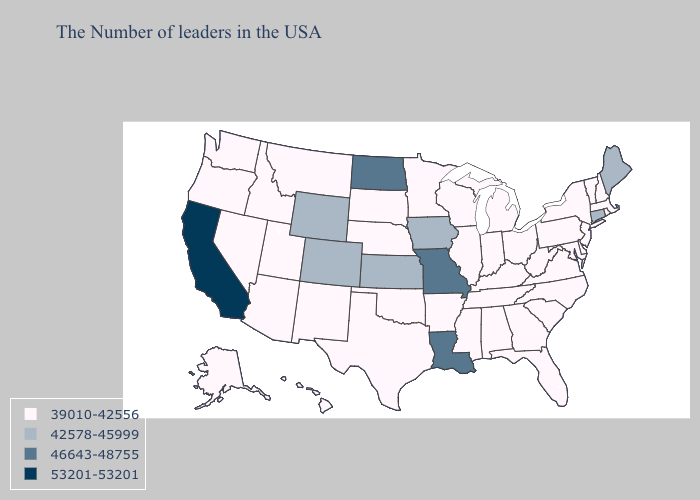Does the first symbol in the legend represent the smallest category?
Quick response, please. Yes. Among the states that border Rhode Island , does Connecticut have the lowest value?
Give a very brief answer. No. Name the states that have a value in the range 53201-53201?
Write a very short answer. California. Which states hav the highest value in the MidWest?
Short answer required. Missouri, North Dakota. Name the states that have a value in the range 53201-53201?
Keep it brief. California. Does the first symbol in the legend represent the smallest category?
Answer briefly. Yes. Which states have the lowest value in the USA?
Quick response, please. Massachusetts, Rhode Island, New Hampshire, Vermont, New York, New Jersey, Delaware, Maryland, Pennsylvania, Virginia, North Carolina, South Carolina, West Virginia, Ohio, Florida, Georgia, Michigan, Kentucky, Indiana, Alabama, Tennessee, Wisconsin, Illinois, Mississippi, Arkansas, Minnesota, Nebraska, Oklahoma, Texas, South Dakota, New Mexico, Utah, Montana, Arizona, Idaho, Nevada, Washington, Oregon, Alaska, Hawaii. Does Rhode Island have a lower value than Delaware?
Give a very brief answer. No. Does the map have missing data?
Write a very short answer. No. What is the value of Oklahoma?
Keep it brief. 39010-42556. Does Connecticut have the lowest value in the USA?
Quick response, please. No. Does Maine have the highest value in the USA?
Quick response, please. No. Does the map have missing data?
Be succinct. No. Does Tennessee have the lowest value in the USA?
Concise answer only. Yes. What is the value of Pennsylvania?
Concise answer only. 39010-42556. 